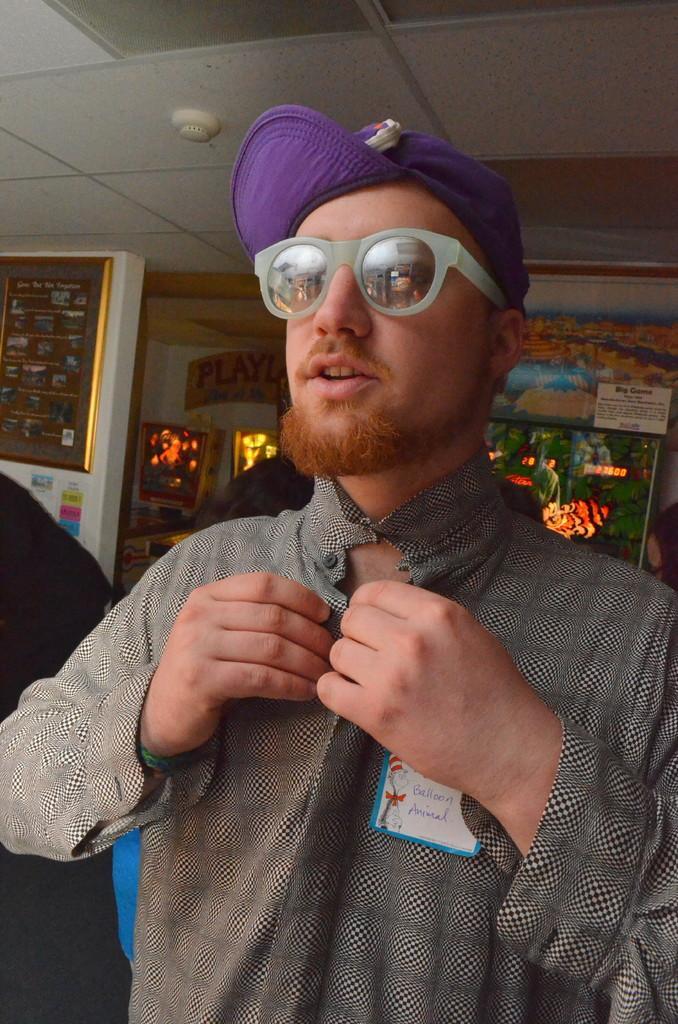Can you describe this image briefly? In this picture there is a boy wearing black and white color shirt with purple cap. Behind there is a decorative lights and golden photo frame on the wall. 